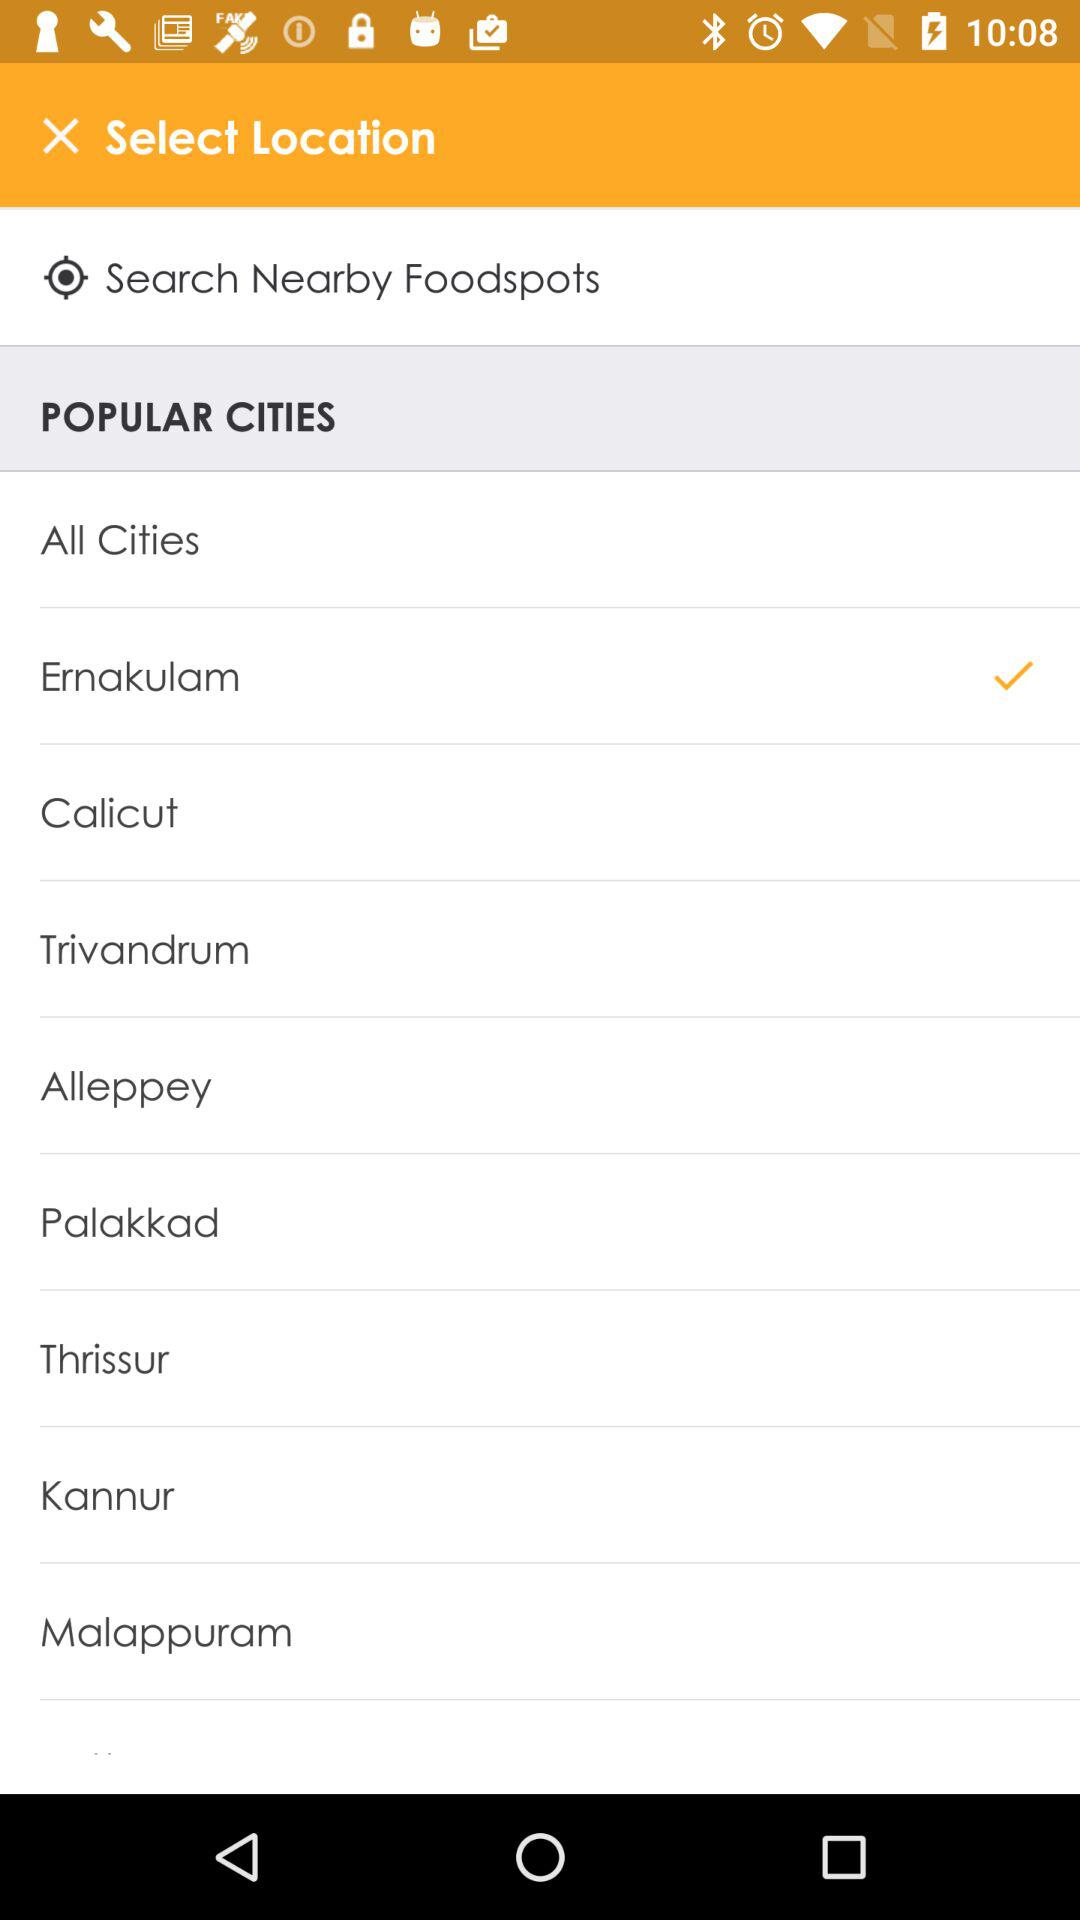How many cities are checked?
Answer the question using a single word or phrase. 1 